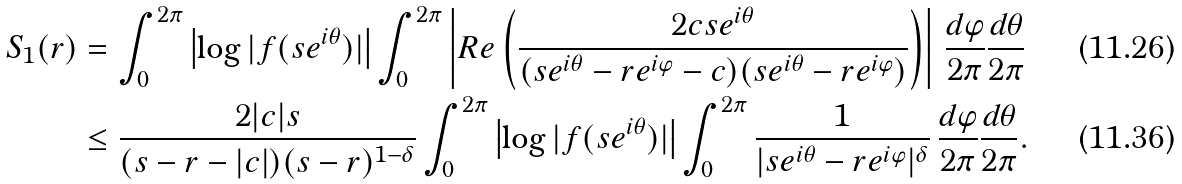<formula> <loc_0><loc_0><loc_500><loc_500>S _ { 1 } ( r ) & = \int _ { 0 } ^ { 2 \pi } \left | \log | f ( s e ^ { i \theta } ) | \right | \int _ { 0 } ^ { 2 \pi } \left | R e \left ( \frac { 2 c s e ^ { i \theta } } { ( s e ^ { i \theta } - r e ^ { i \varphi } - c ) ( s e ^ { i \theta } - r e ^ { i \varphi } ) } \right ) \right | \, \frac { d \varphi } { 2 \pi } \frac { d \theta } { 2 \pi } \\ & \leq \frac { 2 | c | s } { ( s - r - | c | ) ( s - r ) ^ { 1 - \delta } } \int _ { 0 } ^ { 2 \pi } \left | \log | f ( s e ^ { i \theta } ) | \right | \int _ { 0 } ^ { 2 \pi } \frac { 1 } { | s e ^ { i \theta } - r e ^ { i \varphi } | ^ { \delta } } \, \frac { d \varphi } { 2 \pi } \frac { d \theta } { 2 \pi } .</formula> 